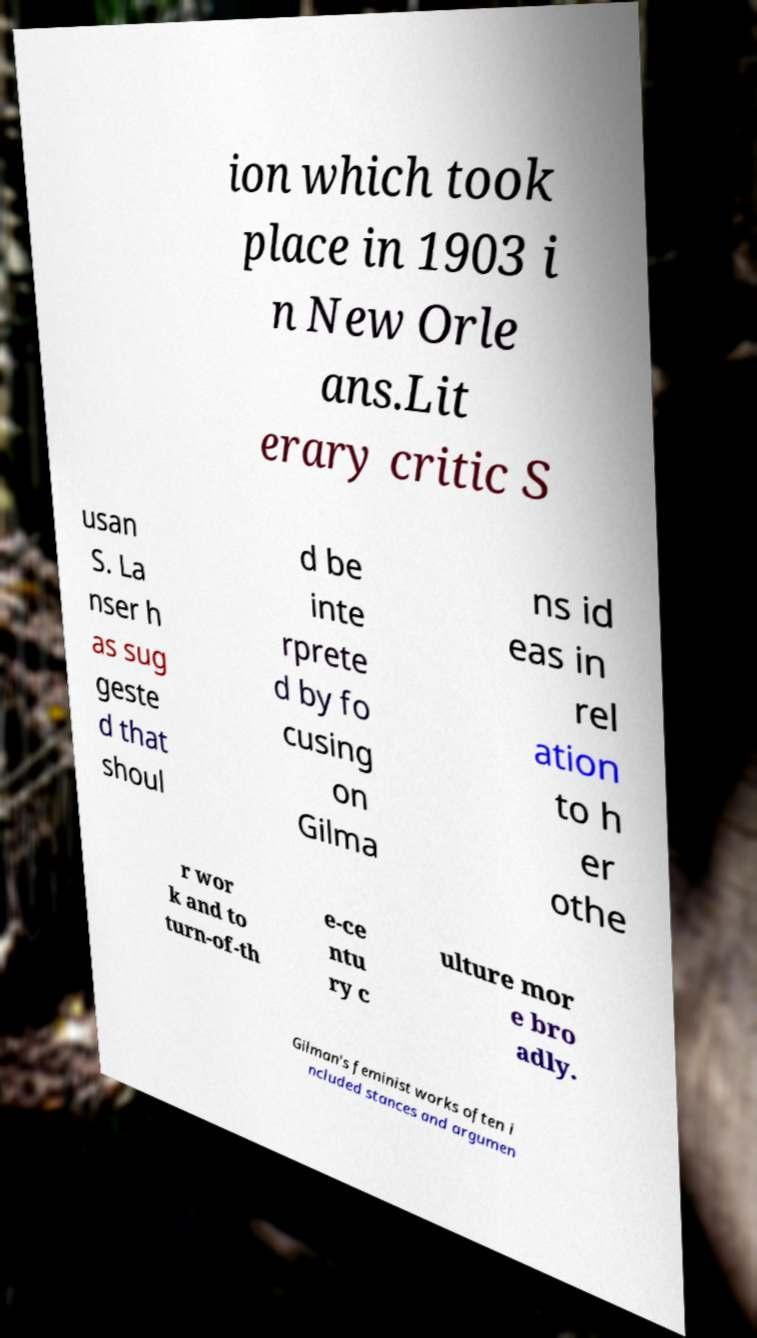For documentation purposes, I need the text within this image transcribed. Could you provide that? ion which took place in 1903 i n New Orle ans.Lit erary critic S usan S. La nser h as sug geste d that shoul d be inte rprete d by fo cusing on Gilma ns id eas in rel ation to h er othe r wor k and to turn-of-th e-ce ntu ry c ulture mor e bro adly. Gilman's feminist works often i ncluded stances and argumen 